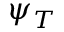<formula> <loc_0><loc_0><loc_500><loc_500>\psi _ { T }</formula> 